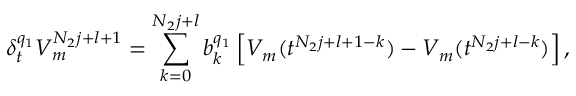<formula> <loc_0><loc_0><loc_500><loc_500>\delta _ { t } ^ { q _ { 1 } } V _ { m } ^ { N _ { 2 } j + l + 1 } = \sum _ { k = 0 } ^ { N _ { 2 } j + l } b _ { k } ^ { q _ { 1 } } \left [ V _ { m } ( t ^ { N _ { 2 } j + l + 1 - k } ) - V _ { m } ( t ^ { N _ { 2 } j + l - k } ) \right ] ,</formula> 